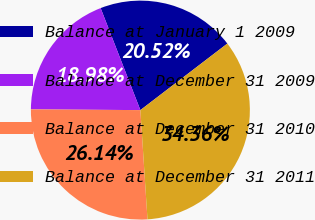Convert chart. <chart><loc_0><loc_0><loc_500><loc_500><pie_chart><fcel>Balance at January 1 2009<fcel>Balance at December 31 2009<fcel>Balance at December 31 2010<fcel>Balance at December 31 2011<nl><fcel>20.52%<fcel>18.98%<fcel>26.14%<fcel>34.36%<nl></chart> 